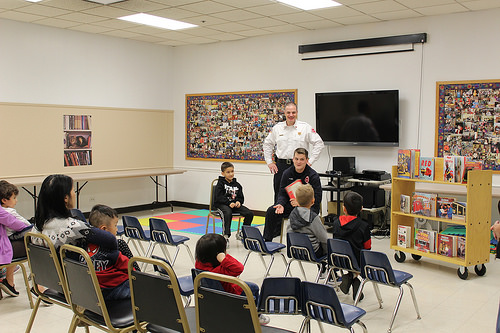<image>
Can you confirm if the table is on the floor? Yes. Looking at the image, I can see the table is positioned on top of the floor, with the floor providing support. 